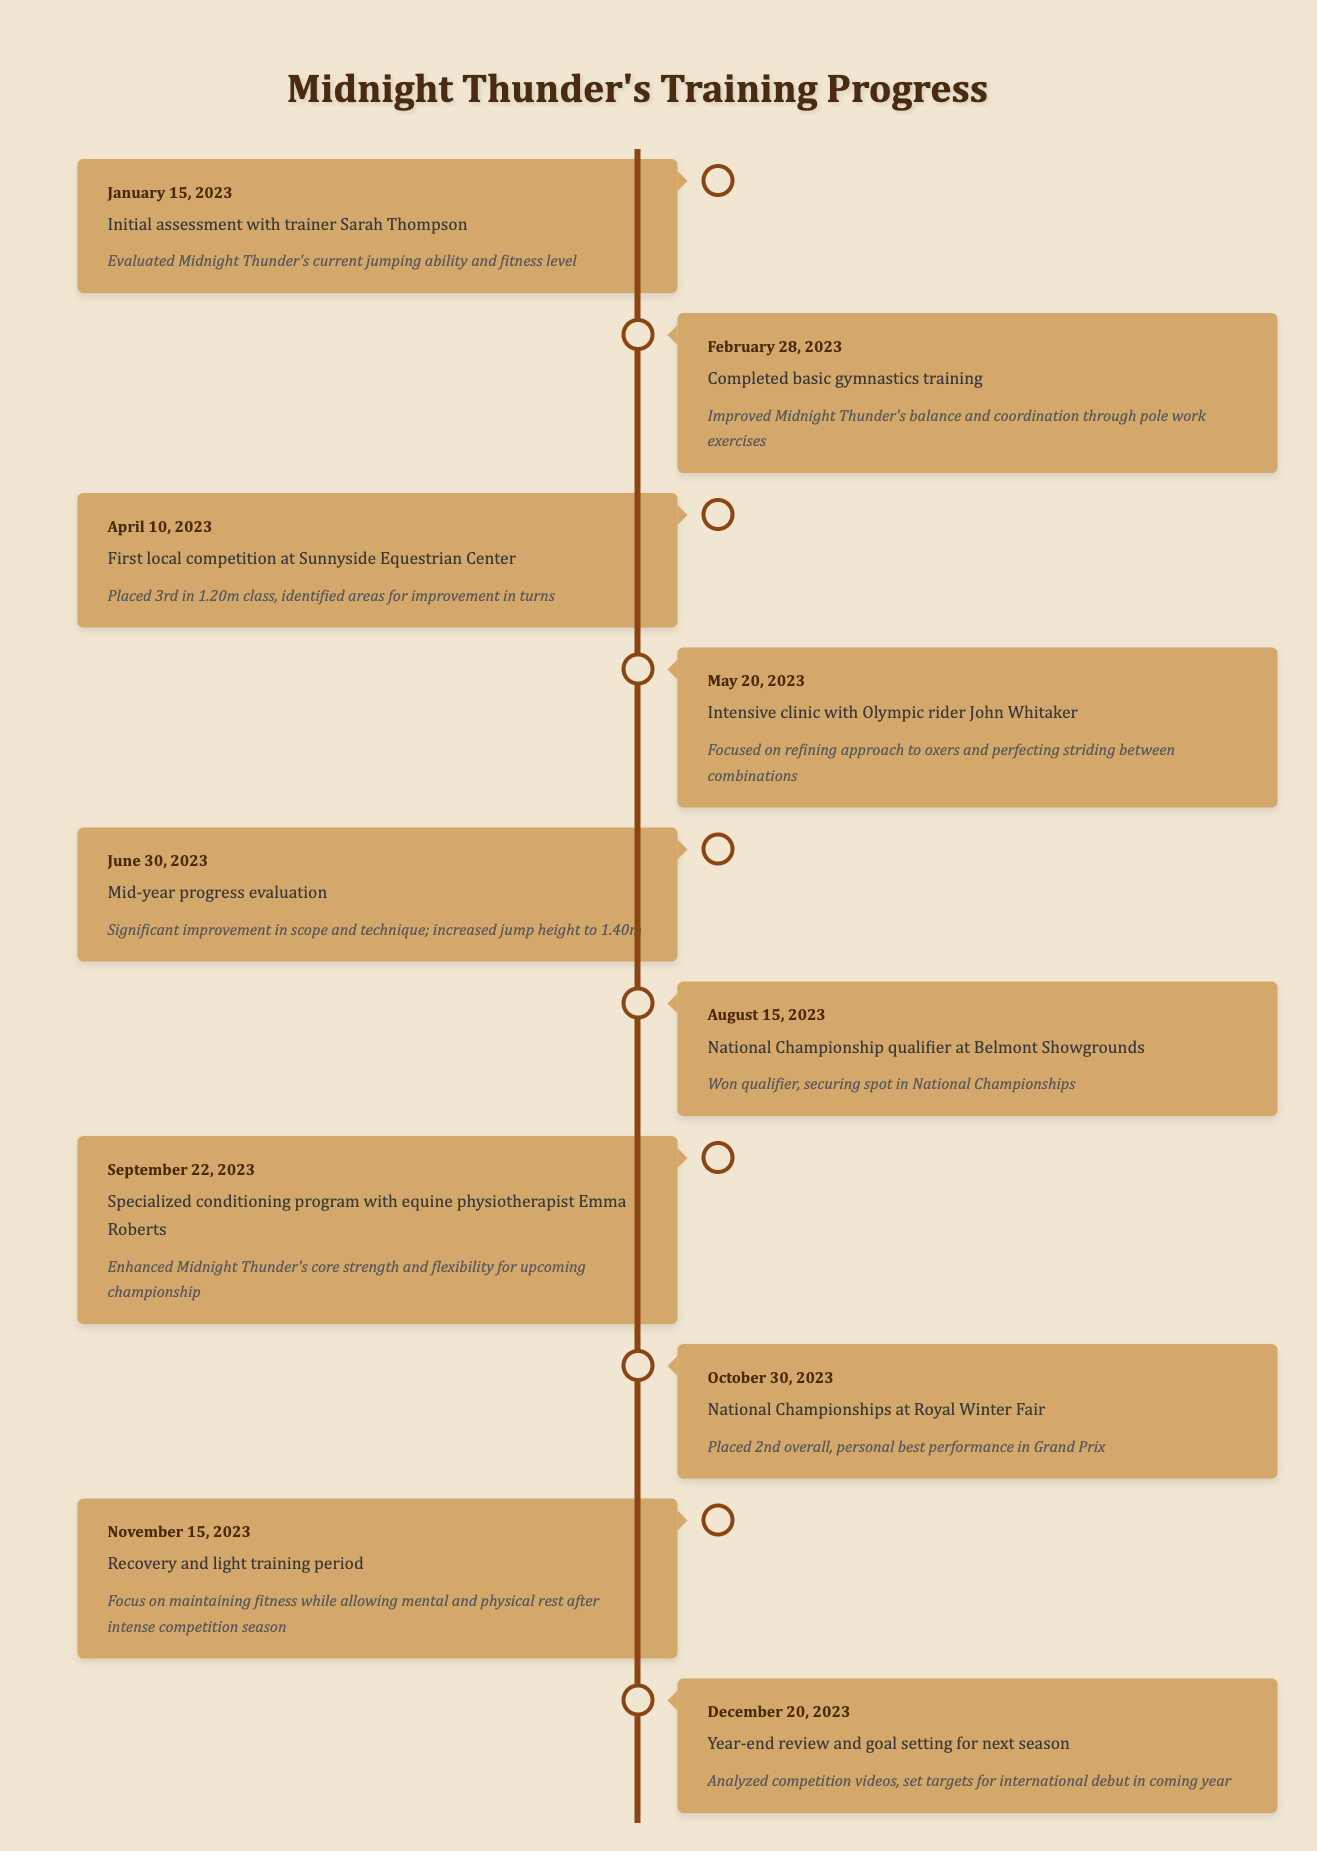What event occurred on June 30, 2023? From the timeline, on June 30, 2023, the event was a mid-year progress evaluation. This detail can be found directly in that specific entry.
Answer: Mid-year progress evaluation How many competitions did Midnight Thunder participate in during the year? By examining the events listed, there are three instances that represent competitions: the local competition on April 10, the national championship qualifier on August 15, and the national championships on October 30. Therefore, Midnight Thunder participated in three competitions.
Answer: 3 What was Midnight Thunder's jump height increase by June 30, 2023? Initially, the timeline does not specify the starting jump height. However, by June 30, 2023, it states that Midnight Thunder increased the jump height to 1.40m. As there is no prior height mentioned in the timeline, it's impossible to determine the exact increase.
Answer: Not determinable Did Midnight Thunder win the national championship qualifier? The timeline states that Midnight Thunder won the qualifier on August 15, 2023, making this a true statement.
Answer: Yes Which event indicates a focus on physical conditioning? The entry on September 22, 2023, discusses a specialized conditioning program with physiotherapist Emma Roberts, which indicates a focus on physical conditioning. This information is centered on enhancing core strength and flexibility.
Answer: Specialized conditioning program How many months elapsed between the initial assessment and the national championships? The initial assessment occurred on January 15, 2023, and the national championships took place on October 30, 2023. Counting the months, from January to October is a total of 9 months elapsed from the first event to the last event.
Answer: 9 What percentage of the year did Midnight Thunder spend in recovery after the national championships? The national championships occurred on October 30, 2023, and the recovery period started on November 15, 2023. There are approximately 15 days between these two dates, totaling about half a month. Since the training timeline spans a full year, the recovery period can be considered as less than 1/12th of the year. However, the recovery phase extends into December, totaling nearly 1.5 months of recovery. Thus, roughly 1.5/12 equals 12.5% is the estimate of the year devoted to recovery.
Answer: 12.5% What key skill was improved through the basic gymnastics training completed on February 28, 2023? The basic gymnastics training specifically improved Midnight Thunder's balance and coordination through pole work exercises, as noted in the details of that event.
Answer: Balance and coordination Identify the event where the highest overall placement was achieved. The national championships held on October 30, 2023, saw Midnight Thunder placing 2nd overall. This was the highest placement recorded in the timeline.
Answer: National Championships, 2nd overall 